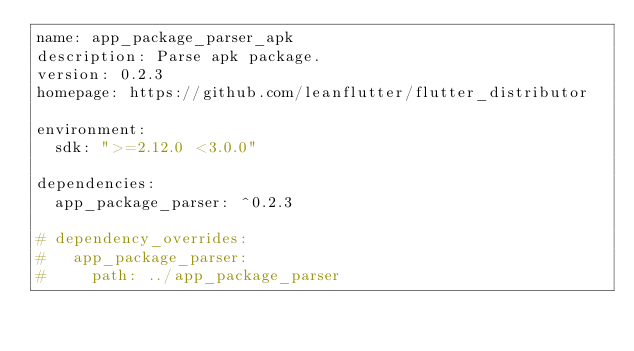Convert code to text. <code><loc_0><loc_0><loc_500><loc_500><_YAML_>name: app_package_parser_apk
description: Parse apk package.
version: 0.2.3
homepage: https://github.com/leanflutter/flutter_distributor

environment:
  sdk: ">=2.12.0 <3.0.0"

dependencies:
  app_package_parser: ^0.2.3

# dependency_overrides:
#   app_package_parser:
#     path: ../app_package_parser
</code> 